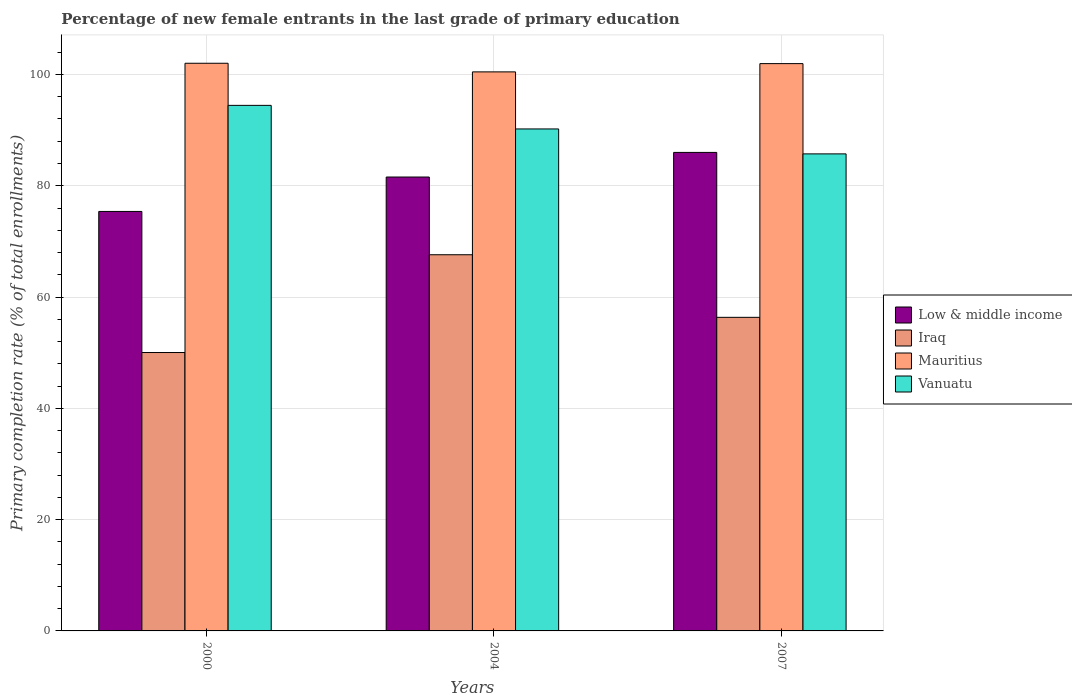How many different coloured bars are there?
Provide a succinct answer. 4. How many groups of bars are there?
Provide a short and direct response. 3. Are the number of bars on each tick of the X-axis equal?
Give a very brief answer. Yes. How many bars are there on the 3rd tick from the right?
Ensure brevity in your answer.  4. What is the percentage of new female entrants in Low & middle income in 2004?
Your answer should be very brief. 81.57. Across all years, what is the maximum percentage of new female entrants in Low & middle income?
Provide a short and direct response. 85.99. Across all years, what is the minimum percentage of new female entrants in Vanuatu?
Offer a very short reply. 85.73. In which year was the percentage of new female entrants in Mauritius maximum?
Provide a succinct answer. 2000. In which year was the percentage of new female entrants in Low & middle income minimum?
Give a very brief answer. 2000. What is the total percentage of new female entrants in Mauritius in the graph?
Your answer should be very brief. 304.42. What is the difference between the percentage of new female entrants in Low & middle income in 2000 and that in 2007?
Offer a very short reply. -10.61. What is the difference between the percentage of new female entrants in Iraq in 2007 and the percentage of new female entrants in Mauritius in 2004?
Make the answer very short. -44.11. What is the average percentage of new female entrants in Vanuatu per year?
Make the answer very short. 90.13. In the year 2004, what is the difference between the percentage of new female entrants in Vanuatu and percentage of new female entrants in Iraq?
Make the answer very short. 22.61. What is the ratio of the percentage of new female entrants in Vanuatu in 2000 to that in 2004?
Provide a short and direct response. 1.05. Is the percentage of new female entrants in Mauritius in 2004 less than that in 2007?
Ensure brevity in your answer.  Yes. Is the difference between the percentage of new female entrants in Vanuatu in 2004 and 2007 greater than the difference between the percentage of new female entrants in Iraq in 2004 and 2007?
Your answer should be very brief. No. What is the difference between the highest and the second highest percentage of new female entrants in Low & middle income?
Offer a very short reply. 4.42. What is the difference between the highest and the lowest percentage of new female entrants in Mauritius?
Make the answer very short. 1.55. In how many years, is the percentage of new female entrants in Vanuatu greater than the average percentage of new female entrants in Vanuatu taken over all years?
Provide a succinct answer. 2. Is the sum of the percentage of new female entrants in Iraq in 2004 and 2007 greater than the maximum percentage of new female entrants in Low & middle income across all years?
Offer a very short reply. Yes. Is it the case that in every year, the sum of the percentage of new female entrants in Low & middle income and percentage of new female entrants in Iraq is greater than the sum of percentage of new female entrants in Vanuatu and percentage of new female entrants in Mauritius?
Your answer should be very brief. Yes. What does the 3rd bar from the right in 2000 represents?
Your answer should be very brief. Iraq. Is it the case that in every year, the sum of the percentage of new female entrants in Vanuatu and percentage of new female entrants in Iraq is greater than the percentage of new female entrants in Mauritius?
Your response must be concise. Yes. Are all the bars in the graph horizontal?
Provide a succinct answer. No. How many years are there in the graph?
Provide a succinct answer. 3. What is the difference between two consecutive major ticks on the Y-axis?
Provide a short and direct response. 20. Does the graph contain any zero values?
Give a very brief answer. No. Does the graph contain grids?
Offer a very short reply. Yes. How many legend labels are there?
Provide a short and direct response. 4. How are the legend labels stacked?
Provide a short and direct response. Vertical. What is the title of the graph?
Your response must be concise. Percentage of new female entrants in the last grade of primary education. What is the label or title of the Y-axis?
Give a very brief answer. Primary completion rate (% of total enrollments). What is the Primary completion rate (% of total enrollments) in Low & middle income in 2000?
Your response must be concise. 75.38. What is the Primary completion rate (% of total enrollments) of Iraq in 2000?
Ensure brevity in your answer.  50.03. What is the Primary completion rate (% of total enrollments) in Mauritius in 2000?
Your response must be concise. 102.01. What is the Primary completion rate (% of total enrollments) in Vanuatu in 2000?
Your response must be concise. 94.44. What is the Primary completion rate (% of total enrollments) in Low & middle income in 2004?
Give a very brief answer. 81.57. What is the Primary completion rate (% of total enrollments) in Iraq in 2004?
Give a very brief answer. 67.6. What is the Primary completion rate (% of total enrollments) in Mauritius in 2004?
Your response must be concise. 100.46. What is the Primary completion rate (% of total enrollments) of Vanuatu in 2004?
Make the answer very short. 90.21. What is the Primary completion rate (% of total enrollments) in Low & middle income in 2007?
Keep it short and to the point. 85.99. What is the Primary completion rate (% of total enrollments) in Iraq in 2007?
Keep it short and to the point. 56.35. What is the Primary completion rate (% of total enrollments) in Mauritius in 2007?
Make the answer very short. 101.95. What is the Primary completion rate (% of total enrollments) in Vanuatu in 2007?
Offer a terse response. 85.73. Across all years, what is the maximum Primary completion rate (% of total enrollments) of Low & middle income?
Ensure brevity in your answer.  85.99. Across all years, what is the maximum Primary completion rate (% of total enrollments) of Iraq?
Provide a short and direct response. 67.6. Across all years, what is the maximum Primary completion rate (% of total enrollments) of Mauritius?
Keep it short and to the point. 102.01. Across all years, what is the maximum Primary completion rate (% of total enrollments) of Vanuatu?
Your answer should be very brief. 94.44. Across all years, what is the minimum Primary completion rate (% of total enrollments) of Low & middle income?
Your response must be concise. 75.38. Across all years, what is the minimum Primary completion rate (% of total enrollments) of Iraq?
Give a very brief answer. 50.03. Across all years, what is the minimum Primary completion rate (% of total enrollments) in Mauritius?
Give a very brief answer. 100.46. Across all years, what is the minimum Primary completion rate (% of total enrollments) in Vanuatu?
Provide a short and direct response. 85.73. What is the total Primary completion rate (% of total enrollments) of Low & middle income in the graph?
Give a very brief answer. 242.94. What is the total Primary completion rate (% of total enrollments) of Iraq in the graph?
Provide a short and direct response. 173.98. What is the total Primary completion rate (% of total enrollments) of Mauritius in the graph?
Keep it short and to the point. 304.42. What is the total Primary completion rate (% of total enrollments) of Vanuatu in the graph?
Your answer should be very brief. 270.38. What is the difference between the Primary completion rate (% of total enrollments) of Low & middle income in 2000 and that in 2004?
Provide a short and direct response. -6.18. What is the difference between the Primary completion rate (% of total enrollments) of Iraq in 2000 and that in 2004?
Ensure brevity in your answer.  -17.57. What is the difference between the Primary completion rate (% of total enrollments) of Mauritius in 2000 and that in 2004?
Provide a succinct answer. 1.55. What is the difference between the Primary completion rate (% of total enrollments) in Vanuatu in 2000 and that in 2004?
Offer a very short reply. 4.24. What is the difference between the Primary completion rate (% of total enrollments) in Low & middle income in 2000 and that in 2007?
Make the answer very short. -10.61. What is the difference between the Primary completion rate (% of total enrollments) of Iraq in 2000 and that in 2007?
Ensure brevity in your answer.  -6.32. What is the difference between the Primary completion rate (% of total enrollments) of Mauritius in 2000 and that in 2007?
Keep it short and to the point. 0.07. What is the difference between the Primary completion rate (% of total enrollments) in Vanuatu in 2000 and that in 2007?
Keep it short and to the point. 8.72. What is the difference between the Primary completion rate (% of total enrollments) of Low & middle income in 2004 and that in 2007?
Provide a succinct answer. -4.42. What is the difference between the Primary completion rate (% of total enrollments) of Iraq in 2004 and that in 2007?
Your answer should be compact. 11.25. What is the difference between the Primary completion rate (% of total enrollments) in Mauritius in 2004 and that in 2007?
Give a very brief answer. -1.48. What is the difference between the Primary completion rate (% of total enrollments) in Vanuatu in 2004 and that in 2007?
Your response must be concise. 4.48. What is the difference between the Primary completion rate (% of total enrollments) of Low & middle income in 2000 and the Primary completion rate (% of total enrollments) of Iraq in 2004?
Your answer should be very brief. 7.78. What is the difference between the Primary completion rate (% of total enrollments) in Low & middle income in 2000 and the Primary completion rate (% of total enrollments) in Mauritius in 2004?
Make the answer very short. -25.08. What is the difference between the Primary completion rate (% of total enrollments) of Low & middle income in 2000 and the Primary completion rate (% of total enrollments) of Vanuatu in 2004?
Your answer should be compact. -14.83. What is the difference between the Primary completion rate (% of total enrollments) of Iraq in 2000 and the Primary completion rate (% of total enrollments) of Mauritius in 2004?
Give a very brief answer. -50.43. What is the difference between the Primary completion rate (% of total enrollments) of Iraq in 2000 and the Primary completion rate (% of total enrollments) of Vanuatu in 2004?
Offer a terse response. -40.18. What is the difference between the Primary completion rate (% of total enrollments) in Mauritius in 2000 and the Primary completion rate (% of total enrollments) in Vanuatu in 2004?
Your answer should be very brief. 11.8. What is the difference between the Primary completion rate (% of total enrollments) of Low & middle income in 2000 and the Primary completion rate (% of total enrollments) of Iraq in 2007?
Provide a short and direct response. 19.03. What is the difference between the Primary completion rate (% of total enrollments) of Low & middle income in 2000 and the Primary completion rate (% of total enrollments) of Mauritius in 2007?
Your answer should be compact. -26.56. What is the difference between the Primary completion rate (% of total enrollments) in Low & middle income in 2000 and the Primary completion rate (% of total enrollments) in Vanuatu in 2007?
Your answer should be very brief. -10.34. What is the difference between the Primary completion rate (% of total enrollments) of Iraq in 2000 and the Primary completion rate (% of total enrollments) of Mauritius in 2007?
Ensure brevity in your answer.  -51.92. What is the difference between the Primary completion rate (% of total enrollments) of Iraq in 2000 and the Primary completion rate (% of total enrollments) of Vanuatu in 2007?
Provide a short and direct response. -35.7. What is the difference between the Primary completion rate (% of total enrollments) of Mauritius in 2000 and the Primary completion rate (% of total enrollments) of Vanuatu in 2007?
Provide a short and direct response. 16.29. What is the difference between the Primary completion rate (% of total enrollments) in Low & middle income in 2004 and the Primary completion rate (% of total enrollments) in Iraq in 2007?
Ensure brevity in your answer.  25.21. What is the difference between the Primary completion rate (% of total enrollments) in Low & middle income in 2004 and the Primary completion rate (% of total enrollments) in Mauritius in 2007?
Make the answer very short. -20.38. What is the difference between the Primary completion rate (% of total enrollments) of Low & middle income in 2004 and the Primary completion rate (% of total enrollments) of Vanuatu in 2007?
Your answer should be compact. -4.16. What is the difference between the Primary completion rate (% of total enrollments) in Iraq in 2004 and the Primary completion rate (% of total enrollments) in Mauritius in 2007?
Your response must be concise. -34.35. What is the difference between the Primary completion rate (% of total enrollments) of Iraq in 2004 and the Primary completion rate (% of total enrollments) of Vanuatu in 2007?
Make the answer very short. -18.12. What is the difference between the Primary completion rate (% of total enrollments) in Mauritius in 2004 and the Primary completion rate (% of total enrollments) in Vanuatu in 2007?
Make the answer very short. 14.74. What is the average Primary completion rate (% of total enrollments) of Low & middle income per year?
Your answer should be very brief. 80.98. What is the average Primary completion rate (% of total enrollments) of Iraq per year?
Make the answer very short. 57.99. What is the average Primary completion rate (% of total enrollments) of Mauritius per year?
Offer a very short reply. 101.47. What is the average Primary completion rate (% of total enrollments) in Vanuatu per year?
Offer a terse response. 90.13. In the year 2000, what is the difference between the Primary completion rate (% of total enrollments) in Low & middle income and Primary completion rate (% of total enrollments) in Iraq?
Make the answer very short. 25.35. In the year 2000, what is the difference between the Primary completion rate (% of total enrollments) of Low & middle income and Primary completion rate (% of total enrollments) of Mauritius?
Ensure brevity in your answer.  -26.63. In the year 2000, what is the difference between the Primary completion rate (% of total enrollments) of Low & middle income and Primary completion rate (% of total enrollments) of Vanuatu?
Your answer should be very brief. -19.06. In the year 2000, what is the difference between the Primary completion rate (% of total enrollments) of Iraq and Primary completion rate (% of total enrollments) of Mauritius?
Provide a succinct answer. -51.98. In the year 2000, what is the difference between the Primary completion rate (% of total enrollments) in Iraq and Primary completion rate (% of total enrollments) in Vanuatu?
Give a very brief answer. -44.42. In the year 2000, what is the difference between the Primary completion rate (% of total enrollments) in Mauritius and Primary completion rate (% of total enrollments) in Vanuatu?
Make the answer very short. 7.57. In the year 2004, what is the difference between the Primary completion rate (% of total enrollments) in Low & middle income and Primary completion rate (% of total enrollments) in Iraq?
Your answer should be compact. 13.97. In the year 2004, what is the difference between the Primary completion rate (% of total enrollments) in Low & middle income and Primary completion rate (% of total enrollments) in Mauritius?
Offer a terse response. -18.89. In the year 2004, what is the difference between the Primary completion rate (% of total enrollments) of Low & middle income and Primary completion rate (% of total enrollments) of Vanuatu?
Provide a short and direct response. -8.64. In the year 2004, what is the difference between the Primary completion rate (% of total enrollments) in Iraq and Primary completion rate (% of total enrollments) in Mauritius?
Give a very brief answer. -32.86. In the year 2004, what is the difference between the Primary completion rate (% of total enrollments) in Iraq and Primary completion rate (% of total enrollments) in Vanuatu?
Provide a short and direct response. -22.61. In the year 2004, what is the difference between the Primary completion rate (% of total enrollments) of Mauritius and Primary completion rate (% of total enrollments) of Vanuatu?
Provide a succinct answer. 10.25. In the year 2007, what is the difference between the Primary completion rate (% of total enrollments) of Low & middle income and Primary completion rate (% of total enrollments) of Iraq?
Your answer should be very brief. 29.64. In the year 2007, what is the difference between the Primary completion rate (% of total enrollments) in Low & middle income and Primary completion rate (% of total enrollments) in Mauritius?
Provide a short and direct response. -15.96. In the year 2007, what is the difference between the Primary completion rate (% of total enrollments) in Low & middle income and Primary completion rate (% of total enrollments) in Vanuatu?
Keep it short and to the point. 0.26. In the year 2007, what is the difference between the Primary completion rate (% of total enrollments) of Iraq and Primary completion rate (% of total enrollments) of Mauritius?
Offer a terse response. -45.59. In the year 2007, what is the difference between the Primary completion rate (% of total enrollments) of Iraq and Primary completion rate (% of total enrollments) of Vanuatu?
Provide a succinct answer. -29.37. In the year 2007, what is the difference between the Primary completion rate (% of total enrollments) of Mauritius and Primary completion rate (% of total enrollments) of Vanuatu?
Keep it short and to the point. 16.22. What is the ratio of the Primary completion rate (% of total enrollments) of Low & middle income in 2000 to that in 2004?
Provide a succinct answer. 0.92. What is the ratio of the Primary completion rate (% of total enrollments) of Iraq in 2000 to that in 2004?
Ensure brevity in your answer.  0.74. What is the ratio of the Primary completion rate (% of total enrollments) in Mauritius in 2000 to that in 2004?
Your answer should be compact. 1.02. What is the ratio of the Primary completion rate (% of total enrollments) of Vanuatu in 2000 to that in 2004?
Provide a succinct answer. 1.05. What is the ratio of the Primary completion rate (% of total enrollments) in Low & middle income in 2000 to that in 2007?
Offer a very short reply. 0.88. What is the ratio of the Primary completion rate (% of total enrollments) of Iraq in 2000 to that in 2007?
Make the answer very short. 0.89. What is the ratio of the Primary completion rate (% of total enrollments) in Vanuatu in 2000 to that in 2007?
Provide a short and direct response. 1.1. What is the ratio of the Primary completion rate (% of total enrollments) of Low & middle income in 2004 to that in 2007?
Make the answer very short. 0.95. What is the ratio of the Primary completion rate (% of total enrollments) of Iraq in 2004 to that in 2007?
Offer a terse response. 1.2. What is the ratio of the Primary completion rate (% of total enrollments) of Mauritius in 2004 to that in 2007?
Your response must be concise. 0.99. What is the ratio of the Primary completion rate (% of total enrollments) in Vanuatu in 2004 to that in 2007?
Your answer should be compact. 1.05. What is the difference between the highest and the second highest Primary completion rate (% of total enrollments) in Low & middle income?
Offer a terse response. 4.42. What is the difference between the highest and the second highest Primary completion rate (% of total enrollments) in Iraq?
Give a very brief answer. 11.25. What is the difference between the highest and the second highest Primary completion rate (% of total enrollments) of Mauritius?
Provide a succinct answer. 0.07. What is the difference between the highest and the second highest Primary completion rate (% of total enrollments) in Vanuatu?
Give a very brief answer. 4.24. What is the difference between the highest and the lowest Primary completion rate (% of total enrollments) in Low & middle income?
Keep it short and to the point. 10.61. What is the difference between the highest and the lowest Primary completion rate (% of total enrollments) in Iraq?
Offer a very short reply. 17.57. What is the difference between the highest and the lowest Primary completion rate (% of total enrollments) in Mauritius?
Give a very brief answer. 1.55. What is the difference between the highest and the lowest Primary completion rate (% of total enrollments) in Vanuatu?
Ensure brevity in your answer.  8.72. 